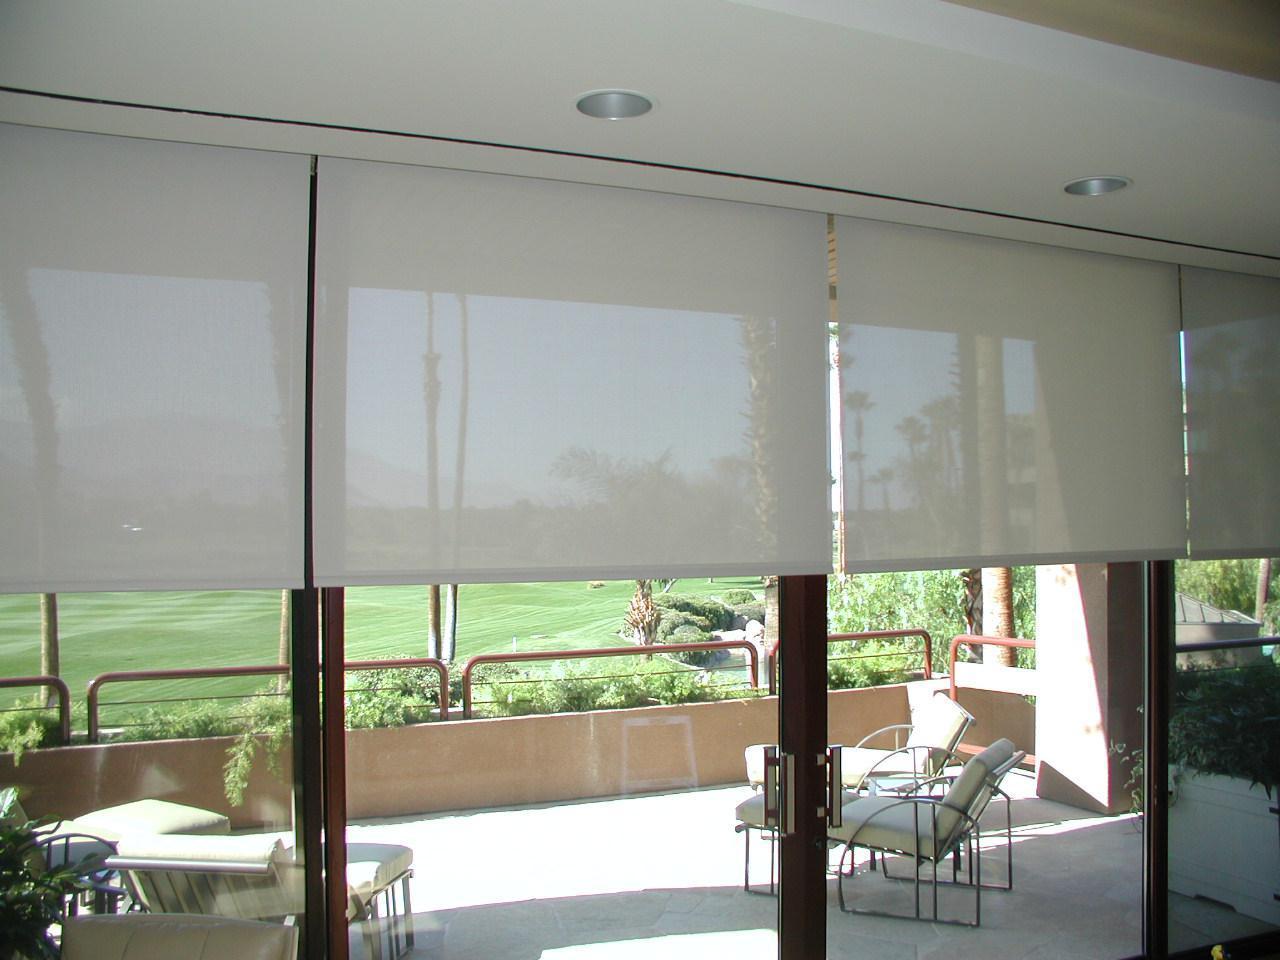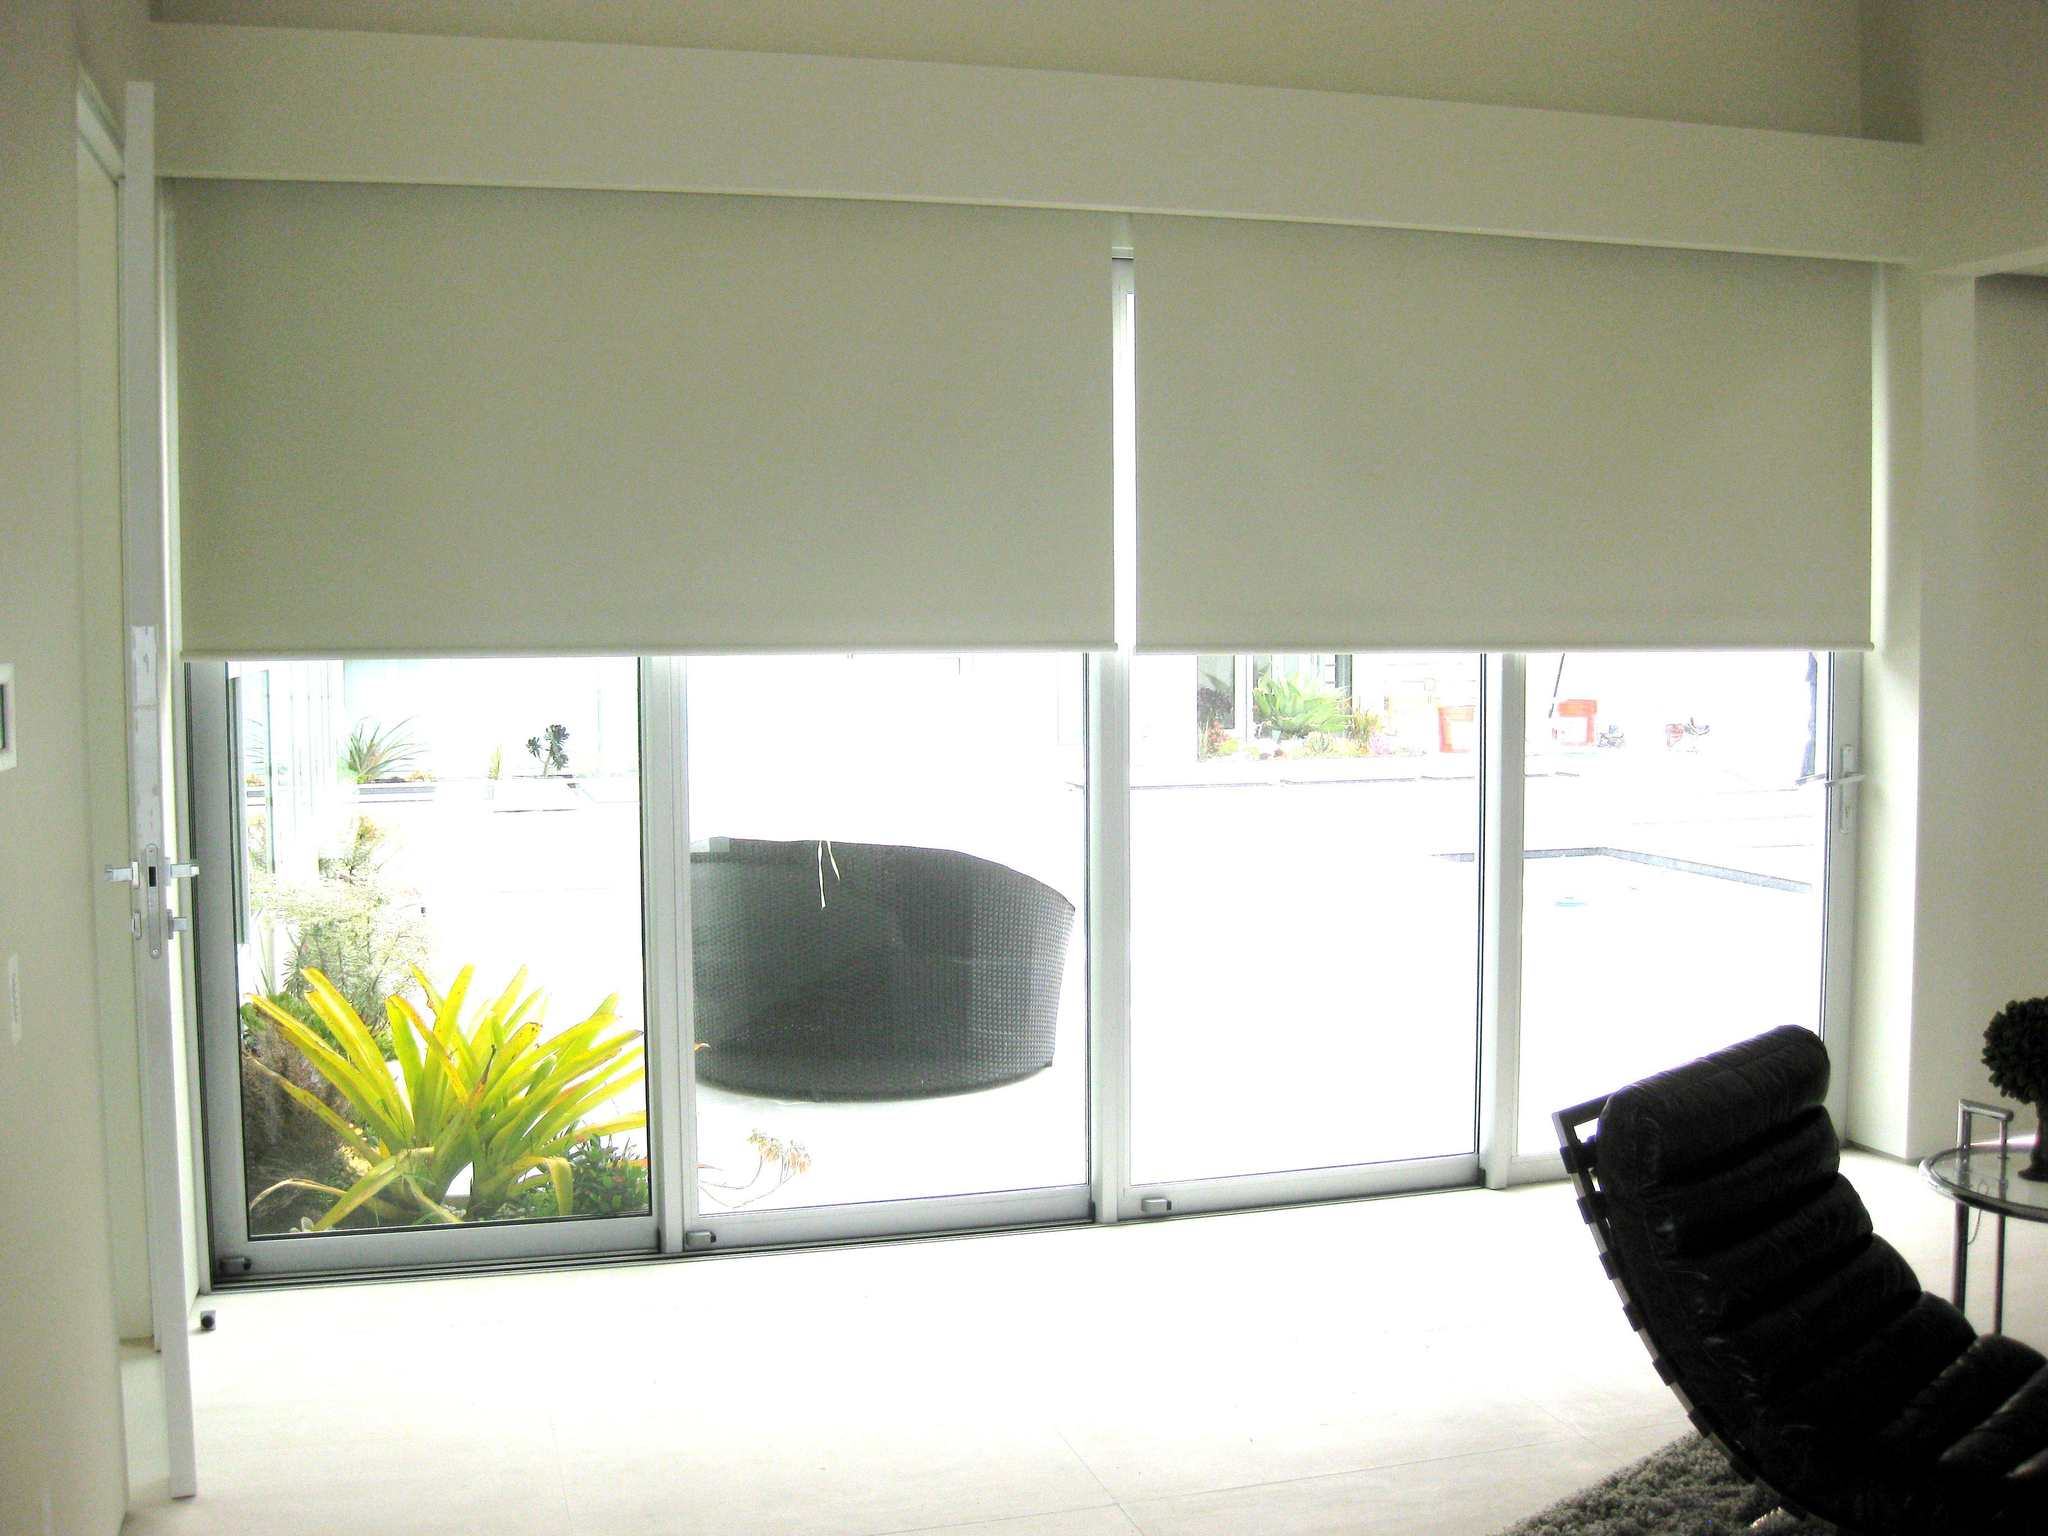The first image is the image on the left, the second image is the image on the right. For the images displayed, is the sentence "There are at least four window panes in one of the images." factually correct? Answer yes or no. Yes. 